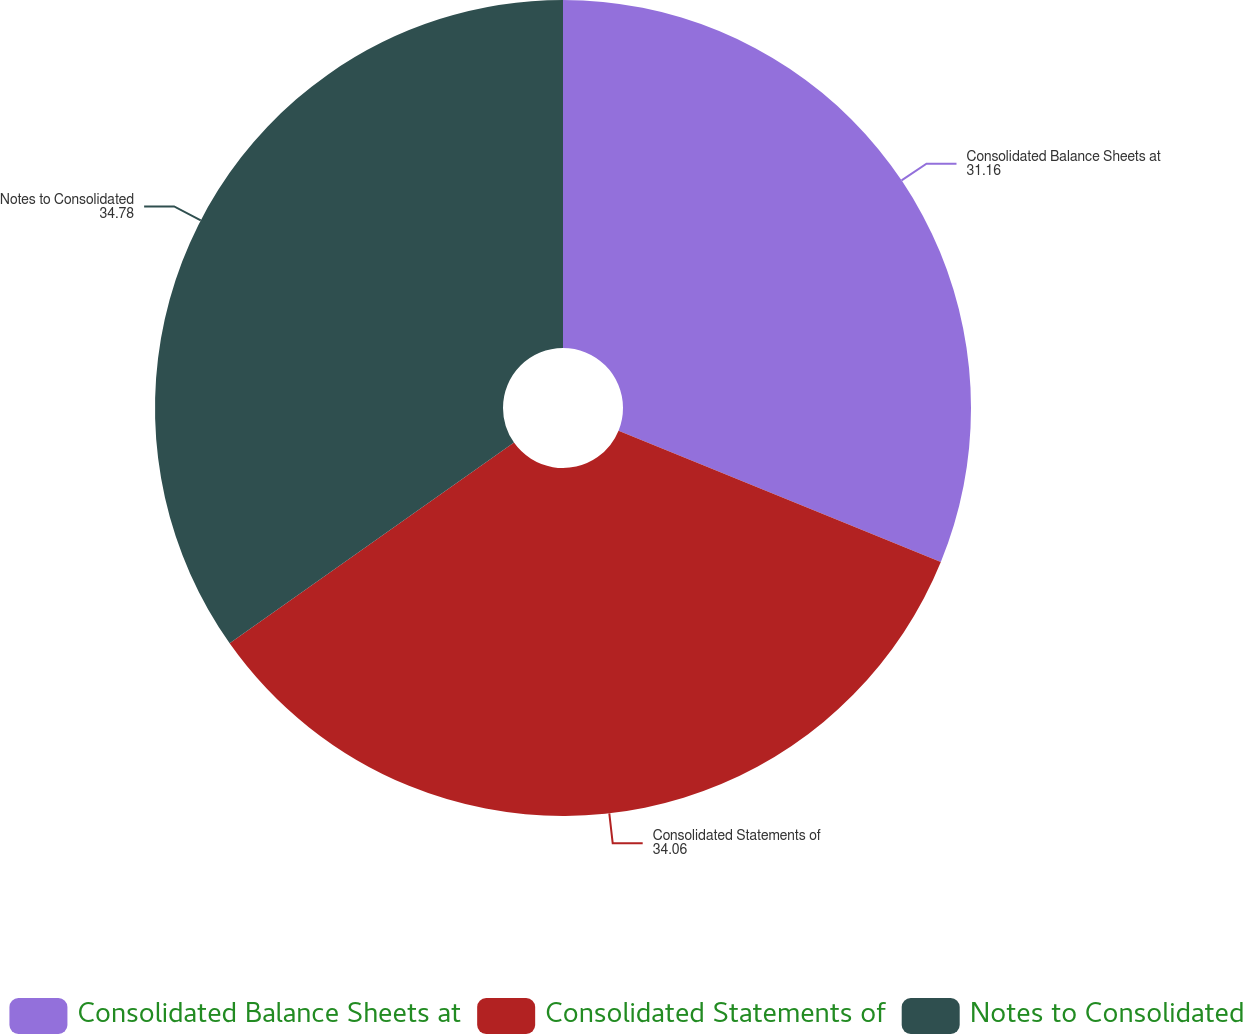Convert chart to OTSL. <chart><loc_0><loc_0><loc_500><loc_500><pie_chart><fcel>Consolidated Balance Sheets at<fcel>Consolidated Statements of<fcel>Notes to Consolidated<nl><fcel>31.16%<fcel>34.06%<fcel>34.78%<nl></chart> 